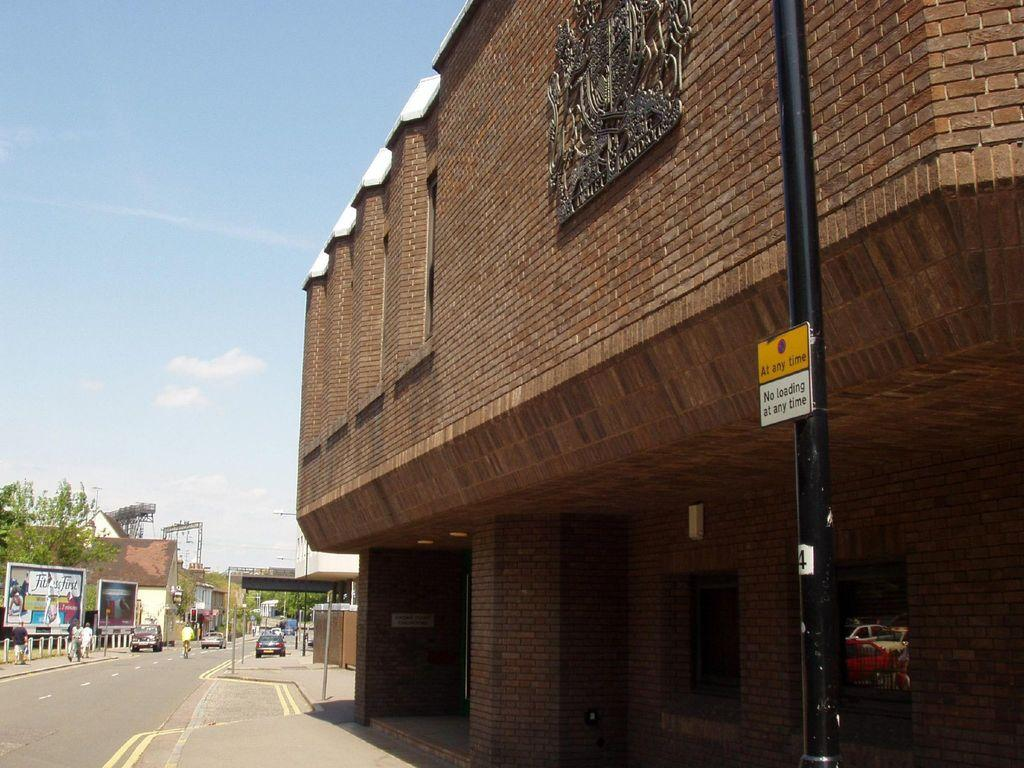What is happening on the road in the image? There are vehicles on the road in the image. What else can be seen near the road in the image? There are people walking near the road in the image. What type of signage is visible in the image? There are banners visible in the image. What type of natural elements are present in the image? There are trees in the image. What type of man-made structures are present in the image? There are buildings in the image. What type of seed is being advertised on the banner in the image? There is no seed being advertised on the banner in the image; the banners do not mention seeds. What type of ring is visible on the finger of the person walking near the road in the image? There is no ring visible on the finger of the person walking near the road in the image. 